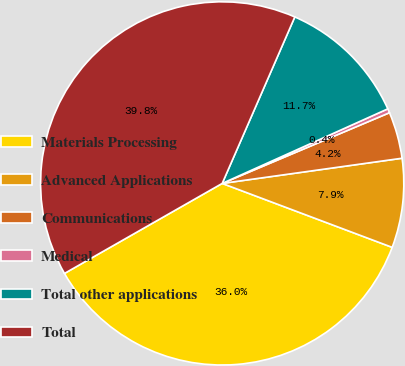Convert chart. <chart><loc_0><loc_0><loc_500><loc_500><pie_chart><fcel>Materials Processing<fcel>Advanced Applications<fcel>Communications<fcel>Medical<fcel>Total other applications<fcel>Total<nl><fcel>36.02%<fcel>7.94%<fcel>4.15%<fcel>0.37%<fcel>11.72%<fcel>39.8%<nl></chart> 